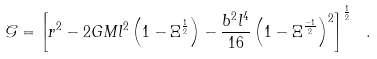Convert formula to latex. <formula><loc_0><loc_0><loc_500><loc_500>\mathcal { G } = \left [ r ^ { 2 } - 2 G M l ^ { 2 } \left ( 1 - \Xi ^ { \frac { 1 } { 2 } } \right ) - \frac { b ^ { 2 } l ^ { 4 } } { 1 6 } \left ( 1 - \Xi ^ { \frac { - 1 } { 2 } } \right ) ^ { 2 } \right ] ^ { \frac { 1 } { 2 } } \ .</formula> 